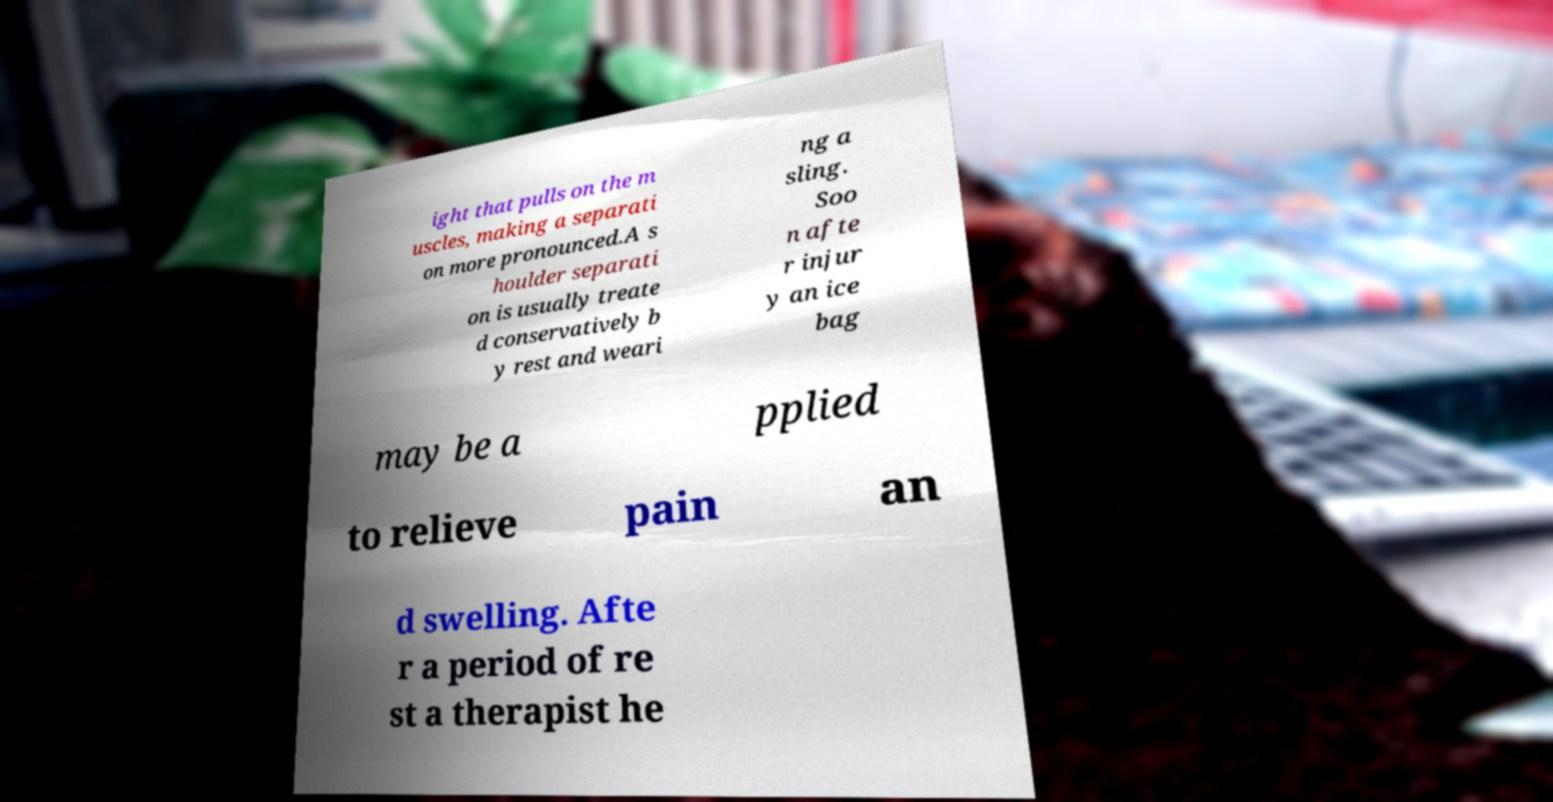Can you accurately transcribe the text from the provided image for me? ight that pulls on the m uscles, making a separati on more pronounced.A s houlder separati on is usually treate d conservatively b y rest and weari ng a sling. Soo n afte r injur y an ice bag may be a pplied to relieve pain an d swelling. Afte r a period of re st a therapist he 